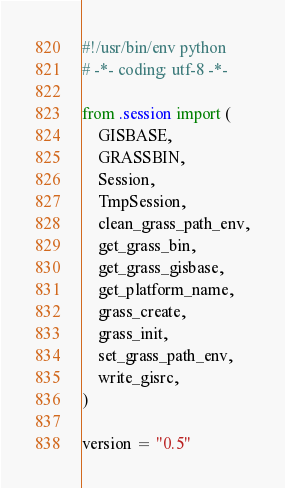<code> <loc_0><loc_0><loc_500><loc_500><_Python_>#!/usr/bin/env python
# -*- coding: utf-8 -*-

from .session import (
    GISBASE,
    GRASSBIN,
    Session,
    TmpSession,
    clean_grass_path_env,
    get_grass_bin,
    get_grass_gisbase,
    get_platform_name,
    grass_create,
    grass_init,
    set_grass_path_env,
    write_gisrc,
)

version = "0.5"
</code> 